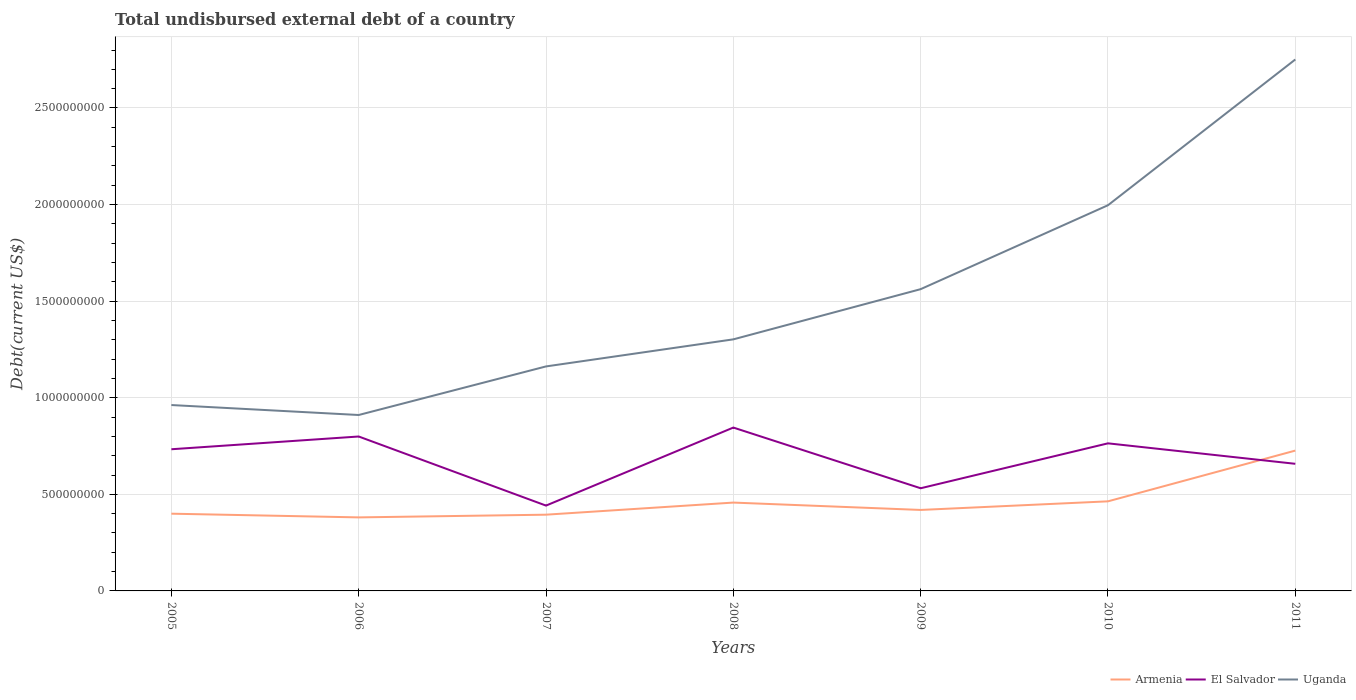How many different coloured lines are there?
Make the answer very short. 3. Across all years, what is the maximum total undisbursed external debt in Uganda?
Keep it short and to the point. 9.11e+08. In which year was the total undisbursed external debt in Uganda maximum?
Your answer should be very brief. 2006. What is the total total undisbursed external debt in El Salvador in the graph?
Offer a very short reply. 7.53e+07. What is the difference between the highest and the second highest total undisbursed external debt in El Salvador?
Provide a short and direct response. 4.04e+08. Is the total undisbursed external debt in El Salvador strictly greater than the total undisbursed external debt in Uganda over the years?
Offer a terse response. Yes. What is the difference between two consecutive major ticks on the Y-axis?
Offer a very short reply. 5.00e+08. Where does the legend appear in the graph?
Provide a short and direct response. Bottom right. How are the legend labels stacked?
Keep it short and to the point. Horizontal. What is the title of the graph?
Give a very brief answer. Total undisbursed external debt of a country. Does "Cuba" appear as one of the legend labels in the graph?
Provide a succinct answer. No. What is the label or title of the Y-axis?
Your answer should be compact. Debt(current US$). What is the Debt(current US$) in Armenia in 2005?
Your answer should be very brief. 4.00e+08. What is the Debt(current US$) in El Salvador in 2005?
Provide a succinct answer. 7.33e+08. What is the Debt(current US$) of Uganda in 2005?
Keep it short and to the point. 9.62e+08. What is the Debt(current US$) in Armenia in 2006?
Provide a succinct answer. 3.81e+08. What is the Debt(current US$) in El Salvador in 2006?
Provide a succinct answer. 7.99e+08. What is the Debt(current US$) in Uganda in 2006?
Your answer should be compact. 9.11e+08. What is the Debt(current US$) of Armenia in 2007?
Ensure brevity in your answer.  3.95e+08. What is the Debt(current US$) of El Salvador in 2007?
Offer a terse response. 4.42e+08. What is the Debt(current US$) in Uganda in 2007?
Offer a very short reply. 1.16e+09. What is the Debt(current US$) of Armenia in 2008?
Offer a very short reply. 4.57e+08. What is the Debt(current US$) in El Salvador in 2008?
Keep it short and to the point. 8.46e+08. What is the Debt(current US$) of Uganda in 2008?
Provide a succinct answer. 1.30e+09. What is the Debt(current US$) of Armenia in 2009?
Offer a very short reply. 4.19e+08. What is the Debt(current US$) in El Salvador in 2009?
Your response must be concise. 5.31e+08. What is the Debt(current US$) of Uganda in 2009?
Provide a short and direct response. 1.56e+09. What is the Debt(current US$) of Armenia in 2010?
Offer a terse response. 4.64e+08. What is the Debt(current US$) in El Salvador in 2010?
Make the answer very short. 7.64e+08. What is the Debt(current US$) in Uganda in 2010?
Give a very brief answer. 2.00e+09. What is the Debt(current US$) of Armenia in 2011?
Your answer should be very brief. 7.26e+08. What is the Debt(current US$) in El Salvador in 2011?
Offer a terse response. 6.58e+08. What is the Debt(current US$) of Uganda in 2011?
Your answer should be compact. 2.75e+09. Across all years, what is the maximum Debt(current US$) in Armenia?
Keep it short and to the point. 7.26e+08. Across all years, what is the maximum Debt(current US$) of El Salvador?
Your answer should be compact. 8.46e+08. Across all years, what is the maximum Debt(current US$) of Uganda?
Ensure brevity in your answer.  2.75e+09. Across all years, what is the minimum Debt(current US$) of Armenia?
Give a very brief answer. 3.81e+08. Across all years, what is the minimum Debt(current US$) in El Salvador?
Give a very brief answer. 4.42e+08. Across all years, what is the minimum Debt(current US$) in Uganda?
Make the answer very short. 9.11e+08. What is the total Debt(current US$) in Armenia in the graph?
Your response must be concise. 3.24e+09. What is the total Debt(current US$) of El Salvador in the graph?
Offer a terse response. 4.77e+09. What is the total Debt(current US$) of Uganda in the graph?
Offer a terse response. 1.06e+1. What is the difference between the Debt(current US$) of Armenia in 2005 and that in 2006?
Offer a terse response. 1.92e+07. What is the difference between the Debt(current US$) of El Salvador in 2005 and that in 2006?
Offer a very short reply. -6.60e+07. What is the difference between the Debt(current US$) of Uganda in 2005 and that in 2006?
Provide a short and direct response. 5.15e+07. What is the difference between the Debt(current US$) of Armenia in 2005 and that in 2007?
Ensure brevity in your answer.  5.16e+06. What is the difference between the Debt(current US$) in El Salvador in 2005 and that in 2007?
Give a very brief answer. 2.92e+08. What is the difference between the Debt(current US$) of Uganda in 2005 and that in 2007?
Provide a short and direct response. -2.00e+08. What is the difference between the Debt(current US$) in Armenia in 2005 and that in 2008?
Ensure brevity in your answer.  -5.75e+07. What is the difference between the Debt(current US$) in El Salvador in 2005 and that in 2008?
Provide a short and direct response. -1.12e+08. What is the difference between the Debt(current US$) in Uganda in 2005 and that in 2008?
Offer a terse response. -3.40e+08. What is the difference between the Debt(current US$) of Armenia in 2005 and that in 2009?
Keep it short and to the point. -1.94e+07. What is the difference between the Debt(current US$) in El Salvador in 2005 and that in 2009?
Your response must be concise. 2.02e+08. What is the difference between the Debt(current US$) of Uganda in 2005 and that in 2009?
Provide a succinct answer. -6.00e+08. What is the difference between the Debt(current US$) of Armenia in 2005 and that in 2010?
Give a very brief answer. -6.39e+07. What is the difference between the Debt(current US$) of El Salvador in 2005 and that in 2010?
Your response must be concise. -3.06e+07. What is the difference between the Debt(current US$) of Uganda in 2005 and that in 2010?
Make the answer very short. -1.03e+09. What is the difference between the Debt(current US$) in Armenia in 2005 and that in 2011?
Offer a very short reply. -3.27e+08. What is the difference between the Debt(current US$) in El Salvador in 2005 and that in 2011?
Offer a terse response. 7.53e+07. What is the difference between the Debt(current US$) of Uganda in 2005 and that in 2011?
Provide a succinct answer. -1.79e+09. What is the difference between the Debt(current US$) in Armenia in 2006 and that in 2007?
Your answer should be compact. -1.40e+07. What is the difference between the Debt(current US$) of El Salvador in 2006 and that in 2007?
Offer a terse response. 3.58e+08. What is the difference between the Debt(current US$) in Uganda in 2006 and that in 2007?
Provide a short and direct response. -2.51e+08. What is the difference between the Debt(current US$) of Armenia in 2006 and that in 2008?
Provide a succinct answer. -7.66e+07. What is the difference between the Debt(current US$) of El Salvador in 2006 and that in 2008?
Keep it short and to the point. -4.63e+07. What is the difference between the Debt(current US$) in Uganda in 2006 and that in 2008?
Ensure brevity in your answer.  -3.92e+08. What is the difference between the Debt(current US$) of Armenia in 2006 and that in 2009?
Give a very brief answer. -3.85e+07. What is the difference between the Debt(current US$) of El Salvador in 2006 and that in 2009?
Provide a short and direct response. 2.68e+08. What is the difference between the Debt(current US$) in Uganda in 2006 and that in 2009?
Your answer should be compact. -6.51e+08. What is the difference between the Debt(current US$) in Armenia in 2006 and that in 2010?
Your answer should be very brief. -8.31e+07. What is the difference between the Debt(current US$) in El Salvador in 2006 and that in 2010?
Your response must be concise. 3.54e+07. What is the difference between the Debt(current US$) of Uganda in 2006 and that in 2010?
Offer a very short reply. -1.09e+09. What is the difference between the Debt(current US$) of Armenia in 2006 and that in 2011?
Make the answer very short. -3.46e+08. What is the difference between the Debt(current US$) of El Salvador in 2006 and that in 2011?
Make the answer very short. 1.41e+08. What is the difference between the Debt(current US$) in Uganda in 2006 and that in 2011?
Provide a succinct answer. -1.84e+09. What is the difference between the Debt(current US$) of Armenia in 2007 and that in 2008?
Give a very brief answer. -6.26e+07. What is the difference between the Debt(current US$) in El Salvador in 2007 and that in 2008?
Offer a terse response. -4.04e+08. What is the difference between the Debt(current US$) in Uganda in 2007 and that in 2008?
Provide a short and direct response. -1.40e+08. What is the difference between the Debt(current US$) of Armenia in 2007 and that in 2009?
Keep it short and to the point. -2.45e+07. What is the difference between the Debt(current US$) of El Salvador in 2007 and that in 2009?
Give a very brief answer. -8.97e+07. What is the difference between the Debt(current US$) of Uganda in 2007 and that in 2009?
Your answer should be very brief. -4.00e+08. What is the difference between the Debt(current US$) of Armenia in 2007 and that in 2010?
Provide a short and direct response. -6.91e+07. What is the difference between the Debt(current US$) of El Salvador in 2007 and that in 2010?
Offer a terse response. -3.22e+08. What is the difference between the Debt(current US$) in Uganda in 2007 and that in 2010?
Keep it short and to the point. -8.34e+08. What is the difference between the Debt(current US$) in Armenia in 2007 and that in 2011?
Offer a terse response. -3.32e+08. What is the difference between the Debt(current US$) in El Salvador in 2007 and that in 2011?
Your answer should be compact. -2.16e+08. What is the difference between the Debt(current US$) in Uganda in 2007 and that in 2011?
Provide a succinct answer. -1.59e+09. What is the difference between the Debt(current US$) of Armenia in 2008 and that in 2009?
Provide a short and direct response. 3.81e+07. What is the difference between the Debt(current US$) in El Salvador in 2008 and that in 2009?
Make the answer very short. 3.14e+08. What is the difference between the Debt(current US$) of Uganda in 2008 and that in 2009?
Your response must be concise. -2.60e+08. What is the difference between the Debt(current US$) in Armenia in 2008 and that in 2010?
Make the answer very short. -6.44e+06. What is the difference between the Debt(current US$) in El Salvador in 2008 and that in 2010?
Ensure brevity in your answer.  8.16e+07. What is the difference between the Debt(current US$) in Uganda in 2008 and that in 2010?
Offer a terse response. -6.94e+08. What is the difference between the Debt(current US$) of Armenia in 2008 and that in 2011?
Ensure brevity in your answer.  -2.69e+08. What is the difference between the Debt(current US$) in El Salvador in 2008 and that in 2011?
Make the answer very short. 1.88e+08. What is the difference between the Debt(current US$) of Uganda in 2008 and that in 2011?
Your answer should be compact. -1.45e+09. What is the difference between the Debt(current US$) in Armenia in 2009 and that in 2010?
Provide a succinct answer. -4.46e+07. What is the difference between the Debt(current US$) of El Salvador in 2009 and that in 2010?
Provide a short and direct response. -2.33e+08. What is the difference between the Debt(current US$) in Uganda in 2009 and that in 2010?
Keep it short and to the point. -4.34e+08. What is the difference between the Debt(current US$) of Armenia in 2009 and that in 2011?
Keep it short and to the point. -3.07e+08. What is the difference between the Debt(current US$) of El Salvador in 2009 and that in 2011?
Give a very brief answer. -1.27e+08. What is the difference between the Debt(current US$) in Uganda in 2009 and that in 2011?
Keep it short and to the point. -1.19e+09. What is the difference between the Debt(current US$) of Armenia in 2010 and that in 2011?
Offer a terse response. -2.63e+08. What is the difference between the Debt(current US$) of El Salvador in 2010 and that in 2011?
Your answer should be very brief. 1.06e+08. What is the difference between the Debt(current US$) of Uganda in 2010 and that in 2011?
Ensure brevity in your answer.  -7.55e+08. What is the difference between the Debt(current US$) of Armenia in 2005 and the Debt(current US$) of El Salvador in 2006?
Ensure brevity in your answer.  -4.00e+08. What is the difference between the Debt(current US$) of Armenia in 2005 and the Debt(current US$) of Uganda in 2006?
Ensure brevity in your answer.  -5.11e+08. What is the difference between the Debt(current US$) of El Salvador in 2005 and the Debt(current US$) of Uganda in 2006?
Your answer should be very brief. -1.77e+08. What is the difference between the Debt(current US$) of Armenia in 2005 and the Debt(current US$) of El Salvador in 2007?
Offer a terse response. -4.19e+07. What is the difference between the Debt(current US$) of Armenia in 2005 and the Debt(current US$) of Uganda in 2007?
Offer a terse response. -7.62e+08. What is the difference between the Debt(current US$) in El Salvador in 2005 and the Debt(current US$) in Uganda in 2007?
Provide a short and direct response. -4.29e+08. What is the difference between the Debt(current US$) of Armenia in 2005 and the Debt(current US$) of El Salvador in 2008?
Offer a very short reply. -4.46e+08. What is the difference between the Debt(current US$) of Armenia in 2005 and the Debt(current US$) of Uganda in 2008?
Provide a succinct answer. -9.02e+08. What is the difference between the Debt(current US$) in El Salvador in 2005 and the Debt(current US$) in Uganda in 2008?
Offer a very short reply. -5.69e+08. What is the difference between the Debt(current US$) in Armenia in 2005 and the Debt(current US$) in El Salvador in 2009?
Offer a very short reply. -1.32e+08. What is the difference between the Debt(current US$) in Armenia in 2005 and the Debt(current US$) in Uganda in 2009?
Your answer should be very brief. -1.16e+09. What is the difference between the Debt(current US$) of El Salvador in 2005 and the Debt(current US$) of Uganda in 2009?
Make the answer very short. -8.29e+08. What is the difference between the Debt(current US$) of Armenia in 2005 and the Debt(current US$) of El Salvador in 2010?
Provide a short and direct response. -3.64e+08. What is the difference between the Debt(current US$) in Armenia in 2005 and the Debt(current US$) in Uganda in 2010?
Provide a succinct answer. -1.60e+09. What is the difference between the Debt(current US$) in El Salvador in 2005 and the Debt(current US$) in Uganda in 2010?
Your answer should be compact. -1.26e+09. What is the difference between the Debt(current US$) in Armenia in 2005 and the Debt(current US$) in El Salvador in 2011?
Your response must be concise. -2.58e+08. What is the difference between the Debt(current US$) of Armenia in 2005 and the Debt(current US$) of Uganda in 2011?
Your response must be concise. -2.35e+09. What is the difference between the Debt(current US$) of El Salvador in 2005 and the Debt(current US$) of Uganda in 2011?
Your answer should be very brief. -2.02e+09. What is the difference between the Debt(current US$) in Armenia in 2006 and the Debt(current US$) in El Salvador in 2007?
Your answer should be compact. -6.11e+07. What is the difference between the Debt(current US$) in Armenia in 2006 and the Debt(current US$) in Uganda in 2007?
Offer a very short reply. -7.81e+08. What is the difference between the Debt(current US$) of El Salvador in 2006 and the Debt(current US$) of Uganda in 2007?
Your answer should be very brief. -3.63e+08. What is the difference between the Debt(current US$) of Armenia in 2006 and the Debt(current US$) of El Salvador in 2008?
Your answer should be very brief. -4.65e+08. What is the difference between the Debt(current US$) in Armenia in 2006 and the Debt(current US$) in Uganda in 2008?
Give a very brief answer. -9.22e+08. What is the difference between the Debt(current US$) in El Salvador in 2006 and the Debt(current US$) in Uganda in 2008?
Provide a short and direct response. -5.03e+08. What is the difference between the Debt(current US$) in Armenia in 2006 and the Debt(current US$) in El Salvador in 2009?
Provide a short and direct response. -1.51e+08. What is the difference between the Debt(current US$) in Armenia in 2006 and the Debt(current US$) in Uganda in 2009?
Keep it short and to the point. -1.18e+09. What is the difference between the Debt(current US$) in El Salvador in 2006 and the Debt(current US$) in Uganda in 2009?
Your answer should be compact. -7.63e+08. What is the difference between the Debt(current US$) in Armenia in 2006 and the Debt(current US$) in El Salvador in 2010?
Give a very brief answer. -3.83e+08. What is the difference between the Debt(current US$) in Armenia in 2006 and the Debt(current US$) in Uganda in 2010?
Provide a short and direct response. -1.62e+09. What is the difference between the Debt(current US$) of El Salvador in 2006 and the Debt(current US$) of Uganda in 2010?
Offer a terse response. -1.20e+09. What is the difference between the Debt(current US$) in Armenia in 2006 and the Debt(current US$) in El Salvador in 2011?
Provide a succinct answer. -2.77e+08. What is the difference between the Debt(current US$) in Armenia in 2006 and the Debt(current US$) in Uganda in 2011?
Give a very brief answer. -2.37e+09. What is the difference between the Debt(current US$) in El Salvador in 2006 and the Debt(current US$) in Uganda in 2011?
Ensure brevity in your answer.  -1.95e+09. What is the difference between the Debt(current US$) in Armenia in 2007 and the Debt(current US$) in El Salvador in 2008?
Keep it short and to the point. -4.51e+08. What is the difference between the Debt(current US$) of Armenia in 2007 and the Debt(current US$) of Uganda in 2008?
Provide a succinct answer. -9.08e+08. What is the difference between the Debt(current US$) in El Salvador in 2007 and the Debt(current US$) in Uganda in 2008?
Your response must be concise. -8.61e+08. What is the difference between the Debt(current US$) of Armenia in 2007 and the Debt(current US$) of El Salvador in 2009?
Give a very brief answer. -1.37e+08. What is the difference between the Debt(current US$) of Armenia in 2007 and the Debt(current US$) of Uganda in 2009?
Your answer should be very brief. -1.17e+09. What is the difference between the Debt(current US$) in El Salvador in 2007 and the Debt(current US$) in Uganda in 2009?
Your answer should be compact. -1.12e+09. What is the difference between the Debt(current US$) in Armenia in 2007 and the Debt(current US$) in El Salvador in 2010?
Offer a terse response. -3.69e+08. What is the difference between the Debt(current US$) in Armenia in 2007 and the Debt(current US$) in Uganda in 2010?
Provide a short and direct response. -1.60e+09. What is the difference between the Debt(current US$) in El Salvador in 2007 and the Debt(current US$) in Uganda in 2010?
Make the answer very short. -1.55e+09. What is the difference between the Debt(current US$) of Armenia in 2007 and the Debt(current US$) of El Salvador in 2011?
Make the answer very short. -2.63e+08. What is the difference between the Debt(current US$) of Armenia in 2007 and the Debt(current US$) of Uganda in 2011?
Give a very brief answer. -2.36e+09. What is the difference between the Debt(current US$) in El Salvador in 2007 and the Debt(current US$) in Uganda in 2011?
Your response must be concise. -2.31e+09. What is the difference between the Debt(current US$) of Armenia in 2008 and the Debt(current US$) of El Salvador in 2009?
Your answer should be very brief. -7.42e+07. What is the difference between the Debt(current US$) in Armenia in 2008 and the Debt(current US$) in Uganda in 2009?
Ensure brevity in your answer.  -1.10e+09. What is the difference between the Debt(current US$) in El Salvador in 2008 and the Debt(current US$) in Uganda in 2009?
Your answer should be compact. -7.17e+08. What is the difference between the Debt(current US$) in Armenia in 2008 and the Debt(current US$) in El Salvador in 2010?
Your answer should be very brief. -3.07e+08. What is the difference between the Debt(current US$) in Armenia in 2008 and the Debt(current US$) in Uganda in 2010?
Your answer should be very brief. -1.54e+09. What is the difference between the Debt(current US$) in El Salvador in 2008 and the Debt(current US$) in Uganda in 2010?
Keep it short and to the point. -1.15e+09. What is the difference between the Debt(current US$) in Armenia in 2008 and the Debt(current US$) in El Salvador in 2011?
Your answer should be compact. -2.01e+08. What is the difference between the Debt(current US$) in Armenia in 2008 and the Debt(current US$) in Uganda in 2011?
Make the answer very short. -2.29e+09. What is the difference between the Debt(current US$) of El Salvador in 2008 and the Debt(current US$) of Uganda in 2011?
Your response must be concise. -1.91e+09. What is the difference between the Debt(current US$) in Armenia in 2009 and the Debt(current US$) in El Salvador in 2010?
Offer a terse response. -3.45e+08. What is the difference between the Debt(current US$) in Armenia in 2009 and the Debt(current US$) in Uganda in 2010?
Provide a succinct answer. -1.58e+09. What is the difference between the Debt(current US$) of El Salvador in 2009 and the Debt(current US$) of Uganda in 2010?
Provide a short and direct response. -1.47e+09. What is the difference between the Debt(current US$) in Armenia in 2009 and the Debt(current US$) in El Salvador in 2011?
Your response must be concise. -2.39e+08. What is the difference between the Debt(current US$) in Armenia in 2009 and the Debt(current US$) in Uganda in 2011?
Provide a succinct answer. -2.33e+09. What is the difference between the Debt(current US$) in El Salvador in 2009 and the Debt(current US$) in Uganda in 2011?
Ensure brevity in your answer.  -2.22e+09. What is the difference between the Debt(current US$) in Armenia in 2010 and the Debt(current US$) in El Salvador in 2011?
Provide a short and direct response. -1.94e+08. What is the difference between the Debt(current US$) in Armenia in 2010 and the Debt(current US$) in Uganda in 2011?
Provide a short and direct response. -2.29e+09. What is the difference between the Debt(current US$) of El Salvador in 2010 and the Debt(current US$) of Uganda in 2011?
Make the answer very short. -1.99e+09. What is the average Debt(current US$) of Armenia per year?
Your response must be concise. 4.63e+08. What is the average Debt(current US$) in El Salvador per year?
Offer a very short reply. 6.82e+08. What is the average Debt(current US$) in Uganda per year?
Make the answer very short. 1.52e+09. In the year 2005, what is the difference between the Debt(current US$) of Armenia and Debt(current US$) of El Salvador?
Make the answer very short. -3.34e+08. In the year 2005, what is the difference between the Debt(current US$) in Armenia and Debt(current US$) in Uganda?
Your response must be concise. -5.62e+08. In the year 2005, what is the difference between the Debt(current US$) in El Salvador and Debt(current US$) in Uganda?
Give a very brief answer. -2.29e+08. In the year 2006, what is the difference between the Debt(current US$) of Armenia and Debt(current US$) of El Salvador?
Ensure brevity in your answer.  -4.19e+08. In the year 2006, what is the difference between the Debt(current US$) in Armenia and Debt(current US$) in Uganda?
Your response must be concise. -5.30e+08. In the year 2006, what is the difference between the Debt(current US$) in El Salvador and Debt(current US$) in Uganda?
Offer a terse response. -1.11e+08. In the year 2007, what is the difference between the Debt(current US$) in Armenia and Debt(current US$) in El Salvador?
Your response must be concise. -4.71e+07. In the year 2007, what is the difference between the Debt(current US$) of Armenia and Debt(current US$) of Uganda?
Provide a succinct answer. -7.67e+08. In the year 2007, what is the difference between the Debt(current US$) in El Salvador and Debt(current US$) in Uganda?
Provide a short and direct response. -7.20e+08. In the year 2008, what is the difference between the Debt(current US$) in Armenia and Debt(current US$) in El Salvador?
Ensure brevity in your answer.  -3.88e+08. In the year 2008, what is the difference between the Debt(current US$) of Armenia and Debt(current US$) of Uganda?
Give a very brief answer. -8.45e+08. In the year 2008, what is the difference between the Debt(current US$) of El Salvador and Debt(current US$) of Uganda?
Keep it short and to the point. -4.57e+08. In the year 2009, what is the difference between the Debt(current US$) of Armenia and Debt(current US$) of El Salvador?
Your response must be concise. -1.12e+08. In the year 2009, what is the difference between the Debt(current US$) of Armenia and Debt(current US$) of Uganda?
Your response must be concise. -1.14e+09. In the year 2009, what is the difference between the Debt(current US$) in El Salvador and Debt(current US$) in Uganda?
Give a very brief answer. -1.03e+09. In the year 2010, what is the difference between the Debt(current US$) in Armenia and Debt(current US$) in El Salvador?
Ensure brevity in your answer.  -3.00e+08. In the year 2010, what is the difference between the Debt(current US$) of Armenia and Debt(current US$) of Uganda?
Ensure brevity in your answer.  -1.53e+09. In the year 2010, what is the difference between the Debt(current US$) of El Salvador and Debt(current US$) of Uganda?
Keep it short and to the point. -1.23e+09. In the year 2011, what is the difference between the Debt(current US$) in Armenia and Debt(current US$) in El Salvador?
Your answer should be compact. 6.84e+07. In the year 2011, what is the difference between the Debt(current US$) of Armenia and Debt(current US$) of Uganda?
Your answer should be very brief. -2.02e+09. In the year 2011, what is the difference between the Debt(current US$) of El Salvador and Debt(current US$) of Uganda?
Offer a terse response. -2.09e+09. What is the ratio of the Debt(current US$) in Armenia in 2005 to that in 2006?
Your answer should be compact. 1.05. What is the ratio of the Debt(current US$) of El Salvador in 2005 to that in 2006?
Give a very brief answer. 0.92. What is the ratio of the Debt(current US$) of Uganda in 2005 to that in 2006?
Your response must be concise. 1.06. What is the ratio of the Debt(current US$) in Armenia in 2005 to that in 2007?
Your answer should be very brief. 1.01. What is the ratio of the Debt(current US$) in El Salvador in 2005 to that in 2007?
Keep it short and to the point. 1.66. What is the ratio of the Debt(current US$) in Uganda in 2005 to that in 2007?
Offer a terse response. 0.83. What is the ratio of the Debt(current US$) in Armenia in 2005 to that in 2008?
Offer a terse response. 0.87. What is the ratio of the Debt(current US$) in El Salvador in 2005 to that in 2008?
Make the answer very short. 0.87. What is the ratio of the Debt(current US$) of Uganda in 2005 to that in 2008?
Your answer should be compact. 0.74. What is the ratio of the Debt(current US$) in Armenia in 2005 to that in 2009?
Your response must be concise. 0.95. What is the ratio of the Debt(current US$) of El Salvador in 2005 to that in 2009?
Give a very brief answer. 1.38. What is the ratio of the Debt(current US$) in Uganda in 2005 to that in 2009?
Your answer should be very brief. 0.62. What is the ratio of the Debt(current US$) in Armenia in 2005 to that in 2010?
Offer a terse response. 0.86. What is the ratio of the Debt(current US$) of El Salvador in 2005 to that in 2010?
Ensure brevity in your answer.  0.96. What is the ratio of the Debt(current US$) of Uganda in 2005 to that in 2010?
Make the answer very short. 0.48. What is the ratio of the Debt(current US$) in Armenia in 2005 to that in 2011?
Provide a succinct answer. 0.55. What is the ratio of the Debt(current US$) of El Salvador in 2005 to that in 2011?
Keep it short and to the point. 1.11. What is the ratio of the Debt(current US$) of Uganda in 2005 to that in 2011?
Your answer should be very brief. 0.35. What is the ratio of the Debt(current US$) in Armenia in 2006 to that in 2007?
Give a very brief answer. 0.96. What is the ratio of the Debt(current US$) of El Salvador in 2006 to that in 2007?
Give a very brief answer. 1.81. What is the ratio of the Debt(current US$) in Uganda in 2006 to that in 2007?
Provide a succinct answer. 0.78. What is the ratio of the Debt(current US$) in Armenia in 2006 to that in 2008?
Offer a terse response. 0.83. What is the ratio of the Debt(current US$) in El Salvador in 2006 to that in 2008?
Ensure brevity in your answer.  0.95. What is the ratio of the Debt(current US$) of Uganda in 2006 to that in 2008?
Your response must be concise. 0.7. What is the ratio of the Debt(current US$) in Armenia in 2006 to that in 2009?
Offer a terse response. 0.91. What is the ratio of the Debt(current US$) in El Salvador in 2006 to that in 2009?
Provide a succinct answer. 1.5. What is the ratio of the Debt(current US$) in Uganda in 2006 to that in 2009?
Provide a succinct answer. 0.58. What is the ratio of the Debt(current US$) in Armenia in 2006 to that in 2010?
Provide a succinct answer. 0.82. What is the ratio of the Debt(current US$) in El Salvador in 2006 to that in 2010?
Offer a terse response. 1.05. What is the ratio of the Debt(current US$) of Uganda in 2006 to that in 2010?
Keep it short and to the point. 0.46. What is the ratio of the Debt(current US$) of Armenia in 2006 to that in 2011?
Your answer should be very brief. 0.52. What is the ratio of the Debt(current US$) in El Salvador in 2006 to that in 2011?
Ensure brevity in your answer.  1.21. What is the ratio of the Debt(current US$) of Uganda in 2006 to that in 2011?
Your answer should be compact. 0.33. What is the ratio of the Debt(current US$) in Armenia in 2007 to that in 2008?
Your answer should be compact. 0.86. What is the ratio of the Debt(current US$) in El Salvador in 2007 to that in 2008?
Offer a very short reply. 0.52. What is the ratio of the Debt(current US$) in Uganda in 2007 to that in 2008?
Offer a terse response. 0.89. What is the ratio of the Debt(current US$) in Armenia in 2007 to that in 2009?
Make the answer very short. 0.94. What is the ratio of the Debt(current US$) of El Salvador in 2007 to that in 2009?
Your response must be concise. 0.83. What is the ratio of the Debt(current US$) in Uganda in 2007 to that in 2009?
Ensure brevity in your answer.  0.74. What is the ratio of the Debt(current US$) of Armenia in 2007 to that in 2010?
Provide a short and direct response. 0.85. What is the ratio of the Debt(current US$) of El Salvador in 2007 to that in 2010?
Your response must be concise. 0.58. What is the ratio of the Debt(current US$) in Uganda in 2007 to that in 2010?
Provide a succinct answer. 0.58. What is the ratio of the Debt(current US$) of Armenia in 2007 to that in 2011?
Make the answer very short. 0.54. What is the ratio of the Debt(current US$) of El Salvador in 2007 to that in 2011?
Your response must be concise. 0.67. What is the ratio of the Debt(current US$) of Uganda in 2007 to that in 2011?
Ensure brevity in your answer.  0.42. What is the ratio of the Debt(current US$) in Armenia in 2008 to that in 2009?
Keep it short and to the point. 1.09. What is the ratio of the Debt(current US$) of El Salvador in 2008 to that in 2009?
Offer a very short reply. 1.59. What is the ratio of the Debt(current US$) of Uganda in 2008 to that in 2009?
Keep it short and to the point. 0.83. What is the ratio of the Debt(current US$) in Armenia in 2008 to that in 2010?
Your answer should be very brief. 0.99. What is the ratio of the Debt(current US$) of El Salvador in 2008 to that in 2010?
Give a very brief answer. 1.11. What is the ratio of the Debt(current US$) in Uganda in 2008 to that in 2010?
Provide a short and direct response. 0.65. What is the ratio of the Debt(current US$) of Armenia in 2008 to that in 2011?
Offer a very short reply. 0.63. What is the ratio of the Debt(current US$) in El Salvador in 2008 to that in 2011?
Your answer should be compact. 1.29. What is the ratio of the Debt(current US$) of Uganda in 2008 to that in 2011?
Make the answer very short. 0.47. What is the ratio of the Debt(current US$) in Armenia in 2009 to that in 2010?
Give a very brief answer. 0.9. What is the ratio of the Debt(current US$) in El Salvador in 2009 to that in 2010?
Offer a very short reply. 0.7. What is the ratio of the Debt(current US$) of Uganda in 2009 to that in 2010?
Offer a terse response. 0.78. What is the ratio of the Debt(current US$) of Armenia in 2009 to that in 2011?
Keep it short and to the point. 0.58. What is the ratio of the Debt(current US$) of El Salvador in 2009 to that in 2011?
Offer a very short reply. 0.81. What is the ratio of the Debt(current US$) of Uganda in 2009 to that in 2011?
Your answer should be compact. 0.57. What is the ratio of the Debt(current US$) of Armenia in 2010 to that in 2011?
Keep it short and to the point. 0.64. What is the ratio of the Debt(current US$) in El Salvador in 2010 to that in 2011?
Your answer should be very brief. 1.16. What is the ratio of the Debt(current US$) in Uganda in 2010 to that in 2011?
Your answer should be very brief. 0.73. What is the difference between the highest and the second highest Debt(current US$) in Armenia?
Keep it short and to the point. 2.63e+08. What is the difference between the highest and the second highest Debt(current US$) of El Salvador?
Offer a terse response. 4.63e+07. What is the difference between the highest and the second highest Debt(current US$) of Uganda?
Offer a very short reply. 7.55e+08. What is the difference between the highest and the lowest Debt(current US$) in Armenia?
Your answer should be very brief. 3.46e+08. What is the difference between the highest and the lowest Debt(current US$) of El Salvador?
Your answer should be compact. 4.04e+08. What is the difference between the highest and the lowest Debt(current US$) of Uganda?
Give a very brief answer. 1.84e+09. 